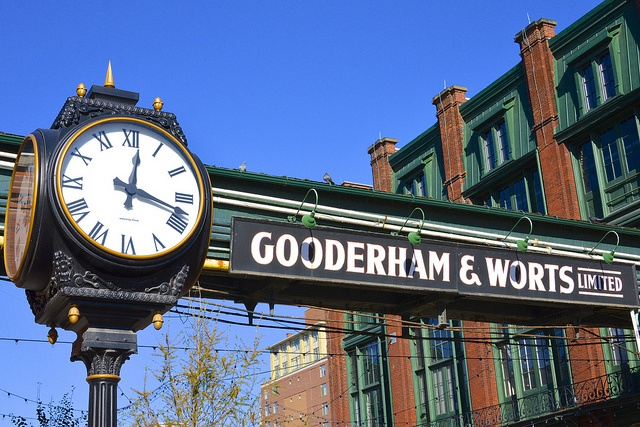Describe the objects in this image and their specific colors. I can see clock in blue, white, and gray tones and clock in blue, gray, darkgray, and black tones in this image. 